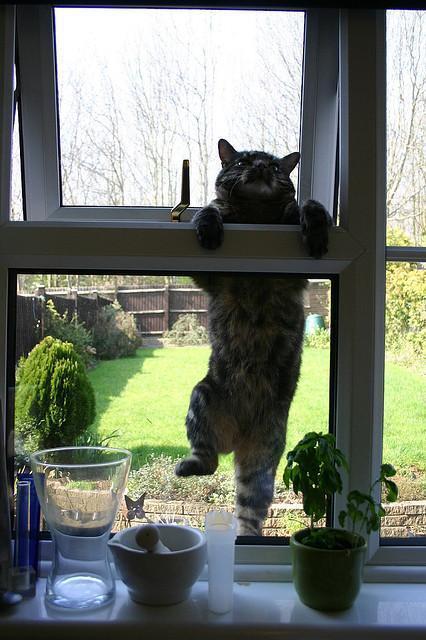How many potted plants are in the picture?
Give a very brief answer. 2. How many buses are in the picture?
Give a very brief answer. 0. 